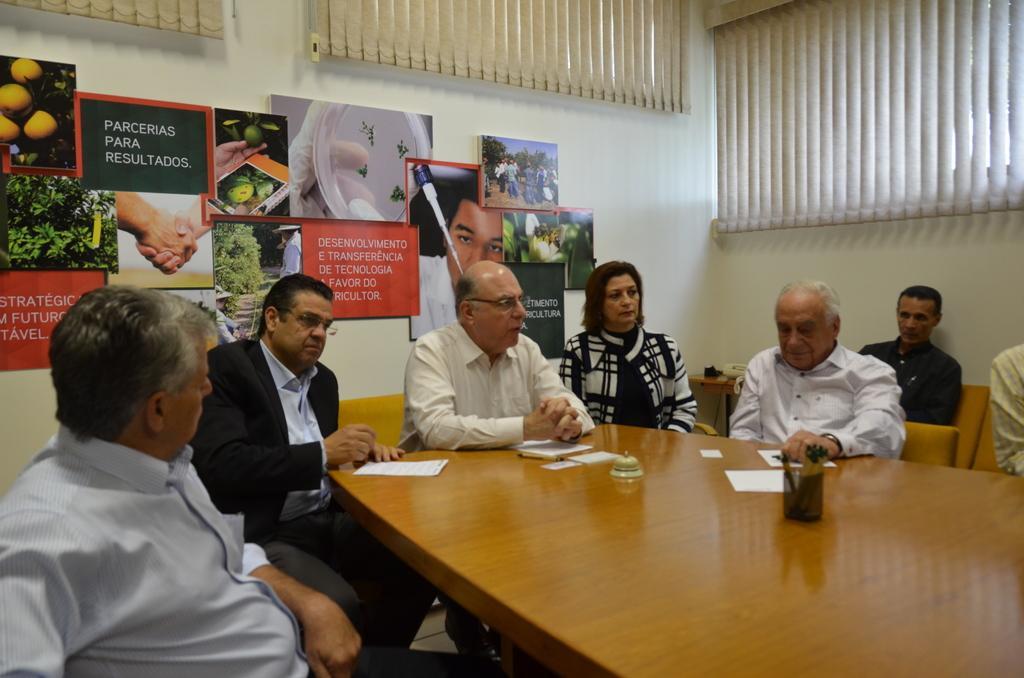Describe this image in one or two sentences. There are few people sat on chairs around the table. The table has pen stand,a bell and few papers on it. Ont to the back side wall there are posters of plants and laboratory equipment. And over to the right side corner there is curtain. 